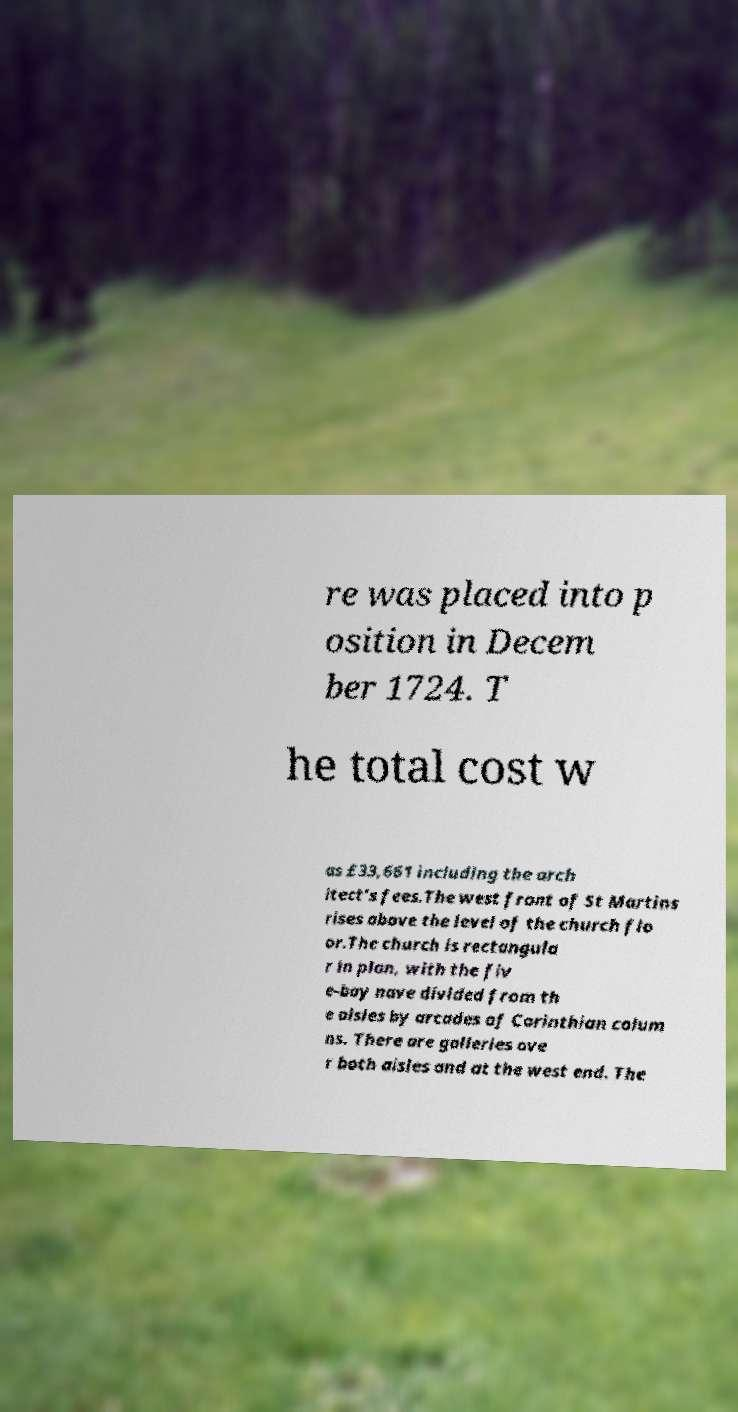Please read and relay the text visible in this image. What does it say? re was placed into p osition in Decem ber 1724. T he total cost w as £33,661 including the arch itect's fees.The west front of St Martins rises above the level of the church flo or.The church is rectangula r in plan, with the fiv e-bay nave divided from th e aisles by arcades of Corinthian colum ns. There are galleries ove r both aisles and at the west end. The 